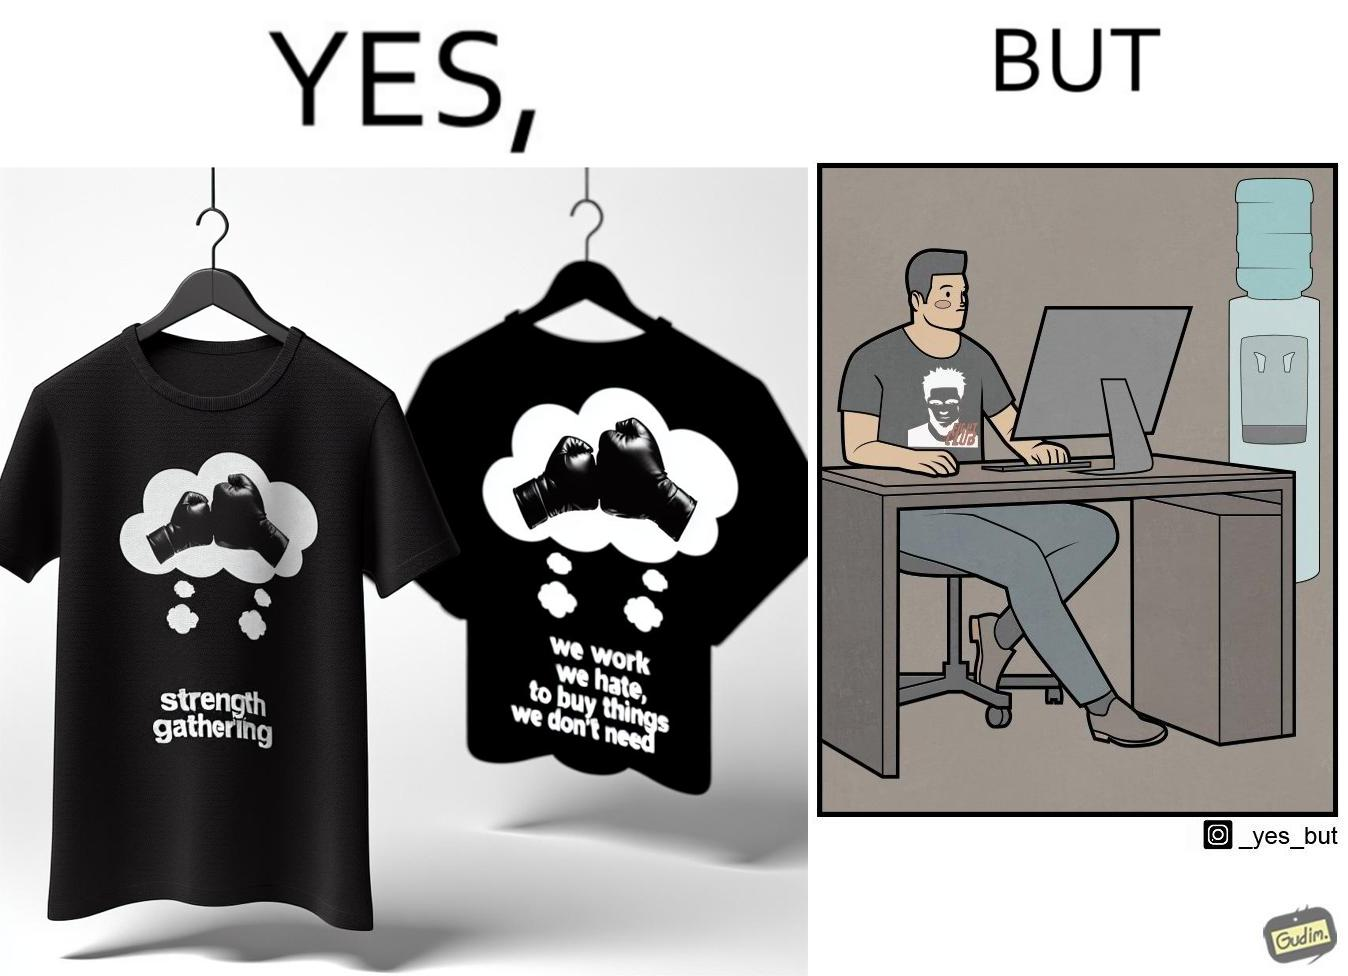What is shown in this image? The image is ironical, as the t-shirt says "We work jobs we hate, to buy sh*t we don't need", which is a rebellious message against the construct of office jobs. However, the person wearing the t-shirt seems to be working in an office environment. Also, the t-shirt might have been bought using the money earned via the very same job. 